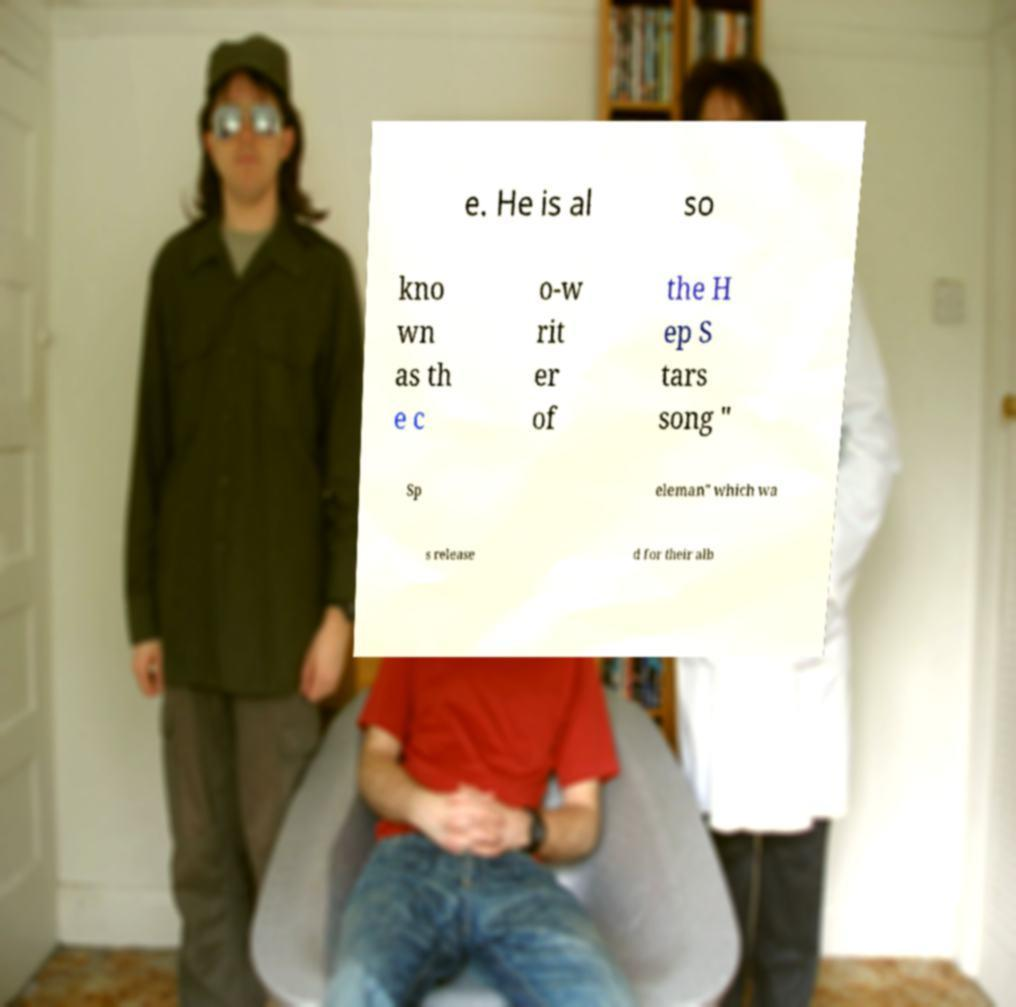What messages or text are displayed in this image? I need them in a readable, typed format. e. He is al so kno wn as th e c o-w rit er of the H ep S tars song " Sp eleman" which wa s release d for their alb 